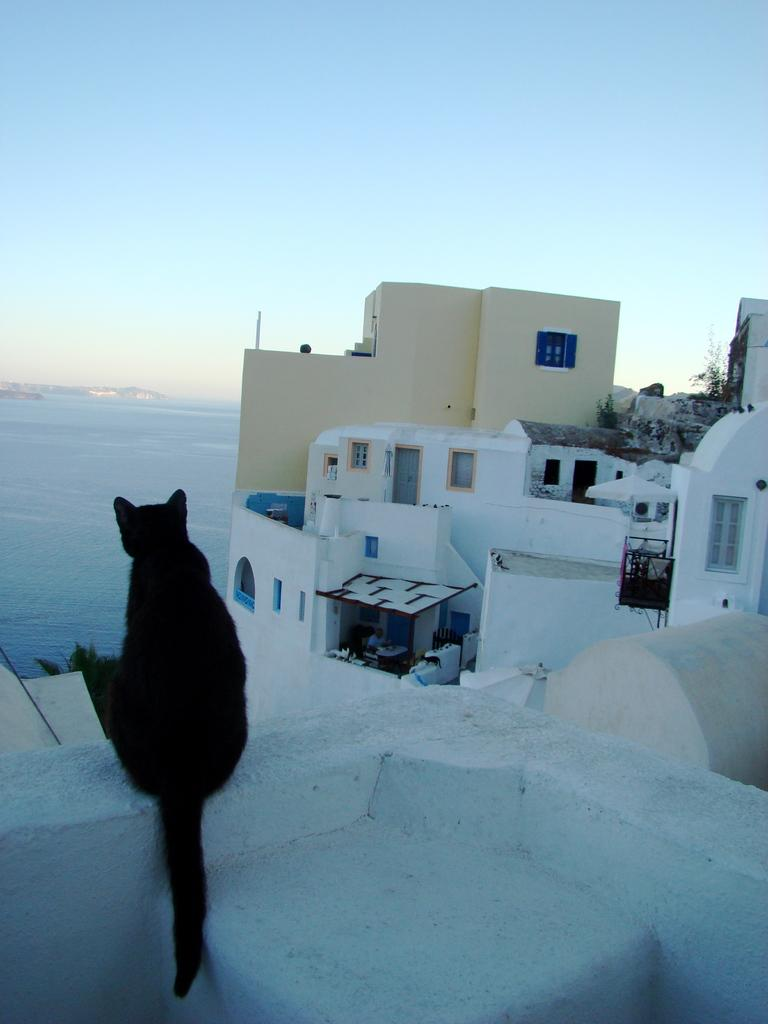What animal can be seen in the image? There is a cat in the image. Where is the cat located? The cat is sitting on the wall of a building. What can be seen in the background of the image? There are buildings and a river in the background of the image. What part of the natural environment is visible in the image? The sky is visible in the background of the image. What type of bait is the cat using to catch fish in the image? There is no bait or fishing activity present in the image; the cat is sitting on the wall of a building. 